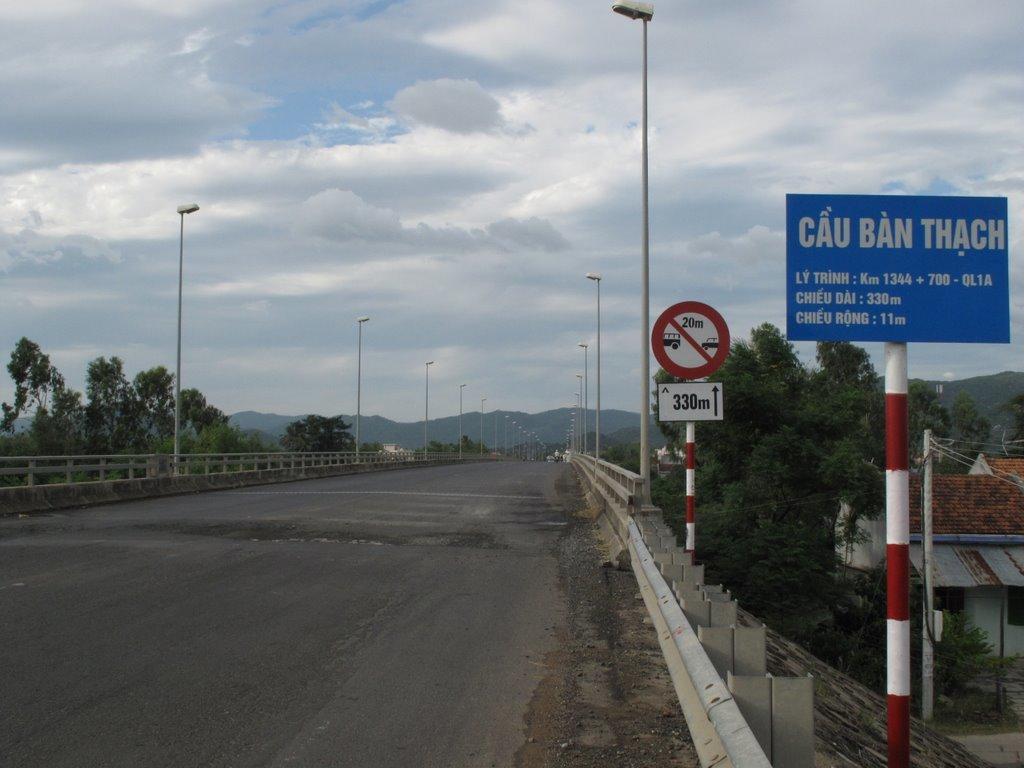What is the blue sign warning you to do?
Ensure brevity in your answer.  Unanswerable. What are the numbers below the red circle?
Your answer should be compact. 330. 